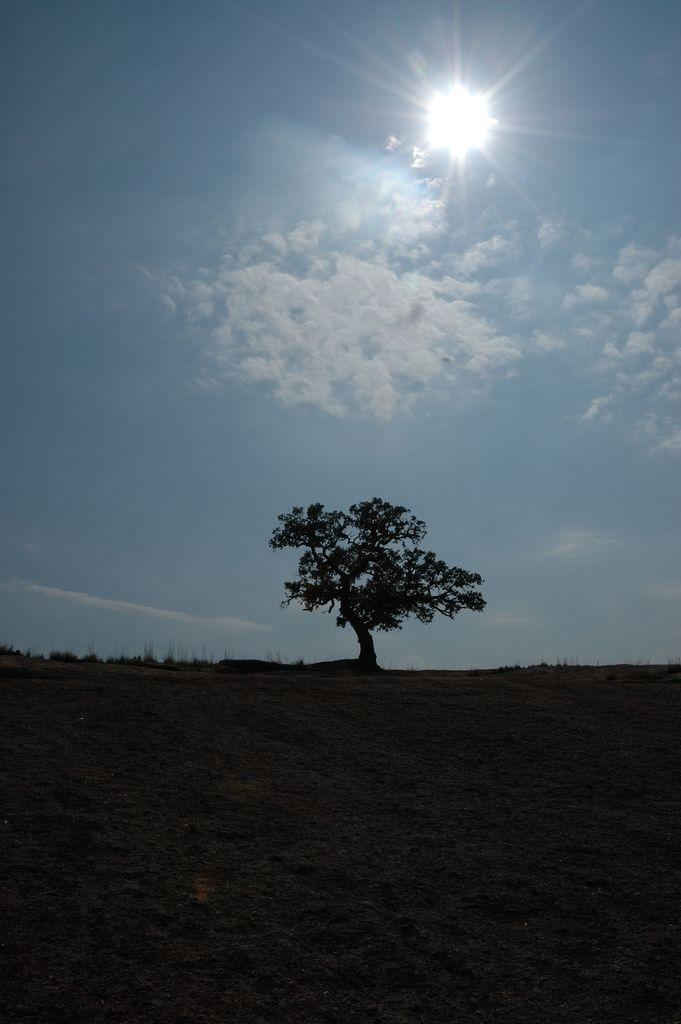What type of natural element can be seen in the image? There is a tree in the image. What part of the natural environment is visible in the image? The sky is visible in the image. Can you describe the celestial body visible in the sky? The sun is visible in the image. What is the lighting condition at the bottom of the image? There is a dark view at the bottom of the image. How many pieces of furniture can be seen in the image? There are no pieces of furniture present in the image. What type of muscle is visible in the image? There are no muscles visible in the image. 